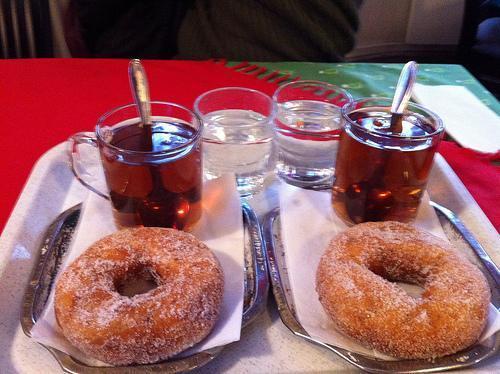How many glasses of water are there?
Give a very brief answer. 2. 